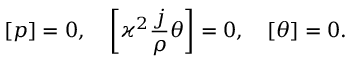Convert formula to latex. <formula><loc_0><loc_0><loc_500><loc_500>\left [ p \right ] = 0 , \quad \left [ \varkappa ^ { 2 } \frac { j } { \rho } \theta \right ] = 0 , \quad \left [ \theta \right ] = 0 .</formula> 